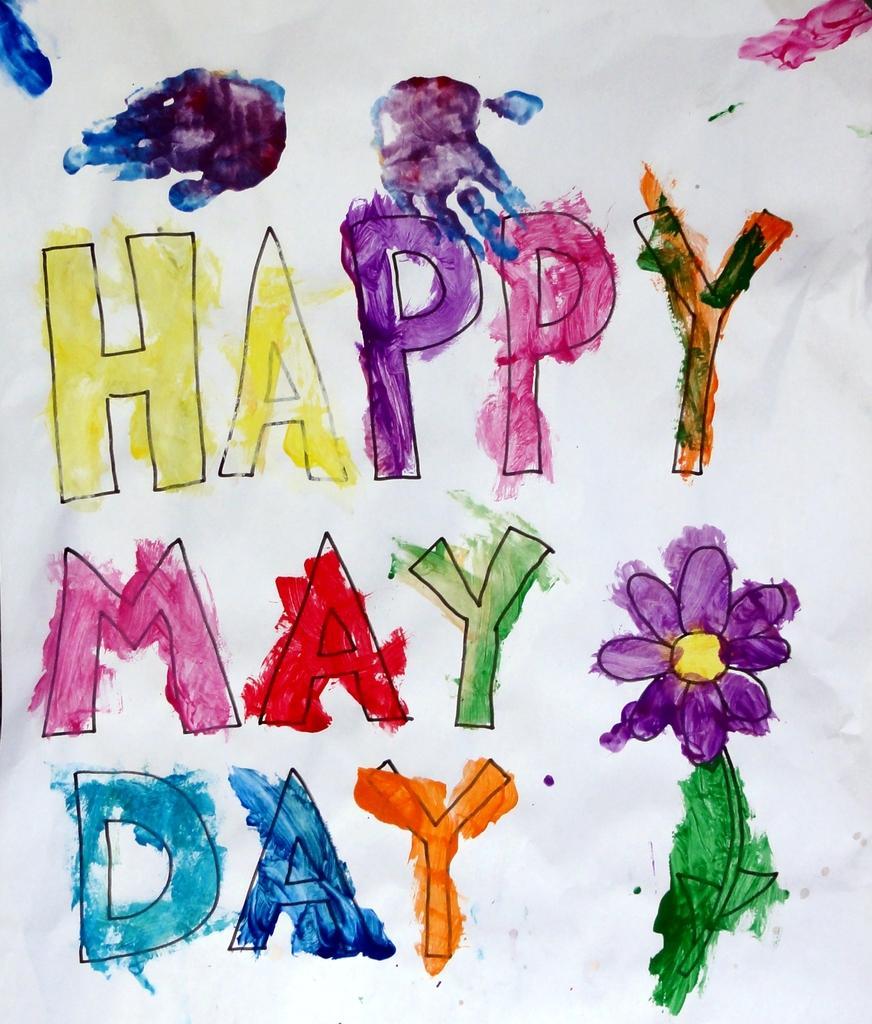In one or two sentences, can you explain what this image depicts? In this image we can see a text and a flower which are painted with watercolors. 